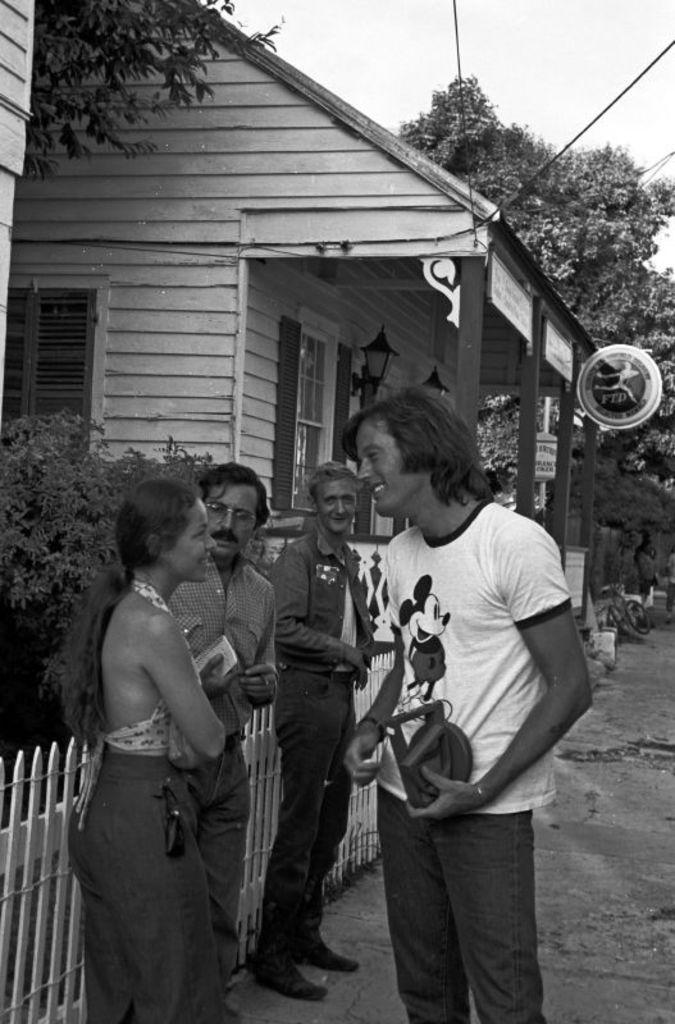What is the color scheme of the image? The image is black and white. What can be seen on the road in the image? There are people standing on the road. What type of barrier is present in the image? There is a wooden fence in the image. What type of vegetation is present in the image? Plants and trees are present in the image. What type of structure can be seen in the image? There is at least one building in the image. What type of lighting is visible in the image? Electric lights are visible in the image. What type of material is visible in the image? Ropes are visible in the image. What part of the natural environment is visible in the image? The sky is visible in the image. What type of cushion is being used by the air in the image? There is no air or cushion present in the image. What does the caption say about the image? There is no caption present in the image. 